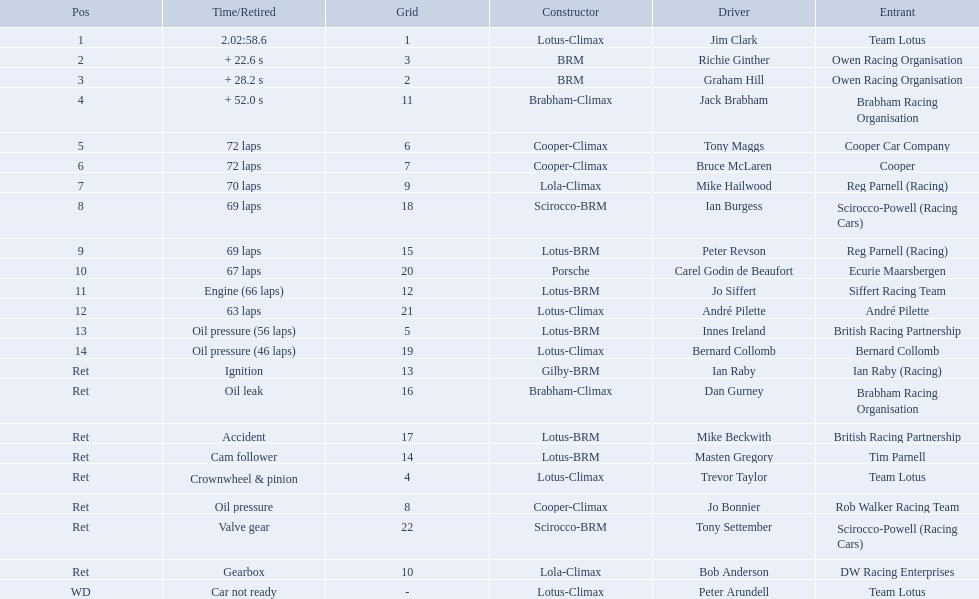Who drove in the 1963 international gold cup? Jim Clark, Richie Ginther, Graham Hill, Jack Brabham, Tony Maggs, Bruce McLaren, Mike Hailwood, Ian Burgess, Peter Revson, Carel Godin de Beaufort, Jo Siffert, André Pilette, Innes Ireland, Bernard Collomb, Ian Raby, Dan Gurney, Mike Beckwith, Masten Gregory, Trevor Taylor, Jo Bonnier, Tony Settember, Bob Anderson, Peter Arundell. Who had problems during the race? Jo Siffert, Innes Ireland, Bernard Collomb, Ian Raby, Dan Gurney, Mike Beckwith, Masten Gregory, Trevor Taylor, Jo Bonnier, Tony Settember, Bob Anderson, Peter Arundell. Of those who was still able to finish the race? Jo Siffert, Innes Ireland, Bernard Collomb. Of those who faced the same issue? Innes Ireland, Bernard Collomb. What issue did they have? Oil pressure. Who were the drivers at the 1963 international gold cup? Jim Clark, Richie Ginther, Graham Hill, Jack Brabham, Tony Maggs, Bruce McLaren, Mike Hailwood, Ian Burgess, Peter Revson, Carel Godin de Beaufort, Jo Siffert, André Pilette, Innes Ireland, Bernard Collomb, Ian Raby, Dan Gurney, Mike Beckwith, Masten Gregory, Trevor Taylor, Jo Bonnier, Tony Settember, Bob Anderson, Peter Arundell. What was tony maggs position? 5. What was jo siffert? 11. Who came in earlier? Tony Maggs. 